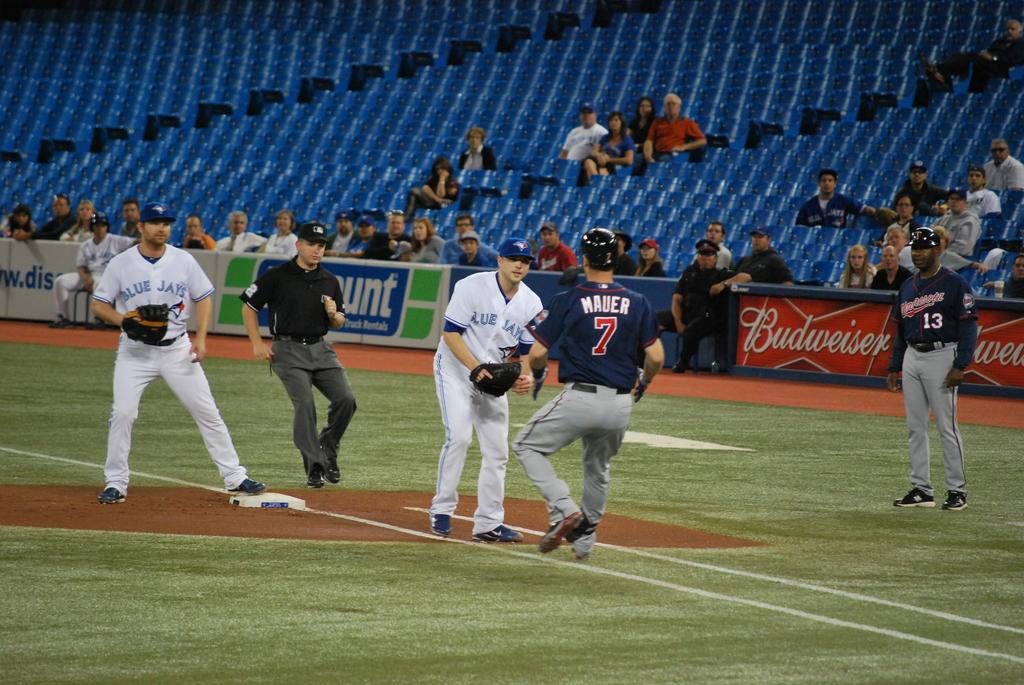What company does the logo in red belong to?
Give a very brief answer. Budweiser. Who is wearing number 7?
Provide a short and direct response. Mauer. 